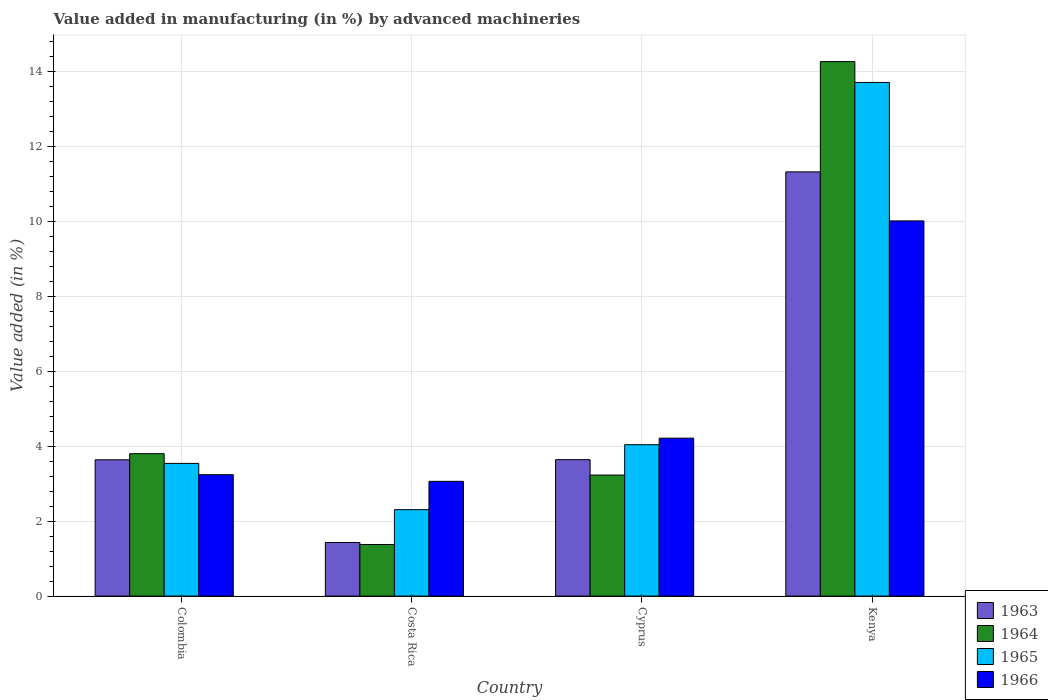How many different coloured bars are there?
Make the answer very short. 4. Are the number of bars on each tick of the X-axis equal?
Offer a terse response. Yes. How many bars are there on the 2nd tick from the left?
Provide a short and direct response. 4. How many bars are there on the 4th tick from the right?
Keep it short and to the point. 4. What is the label of the 4th group of bars from the left?
Give a very brief answer. Kenya. In how many cases, is the number of bars for a given country not equal to the number of legend labels?
Provide a succinct answer. 0. What is the percentage of value added in manufacturing by advanced machineries in 1965 in Kenya?
Offer a terse response. 13.71. Across all countries, what is the maximum percentage of value added in manufacturing by advanced machineries in 1965?
Your answer should be very brief. 13.71. Across all countries, what is the minimum percentage of value added in manufacturing by advanced machineries in 1963?
Provide a short and direct response. 1.43. In which country was the percentage of value added in manufacturing by advanced machineries in 1963 maximum?
Offer a terse response. Kenya. In which country was the percentage of value added in manufacturing by advanced machineries in 1964 minimum?
Your answer should be compact. Costa Rica. What is the total percentage of value added in manufacturing by advanced machineries in 1964 in the graph?
Make the answer very short. 22.68. What is the difference between the percentage of value added in manufacturing by advanced machineries in 1966 in Cyprus and that in Kenya?
Your answer should be compact. -5.8. What is the difference between the percentage of value added in manufacturing by advanced machineries in 1963 in Cyprus and the percentage of value added in manufacturing by advanced machineries in 1965 in Kenya?
Ensure brevity in your answer.  -10.07. What is the average percentage of value added in manufacturing by advanced machineries in 1966 per country?
Offer a very short reply. 5.13. What is the difference between the percentage of value added in manufacturing by advanced machineries of/in 1964 and percentage of value added in manufacturing by advanced machineries of/in 1966 in Colombia?
Provide a succinct answer. 0.56. What is the ratio of the percentage of value added in manufacturing by advanced machineries in 1966 in Costa Rica to that in Cyprus?
Your answer should be very brief. 0.73. What is the difference between the highest and the second highest percentage of value added in manufacturing by advanced machineries in 1966?
Give a very brief answer. 6.77. What is the difference between the highest and the lowest percentage of value added in manufacturing by advanced machineries in 1963?
Keep it short and to the point. 9.89. Is the sum of the percentage of value added in manufacturing by advanced machineries in 1964 in Colombia and Kenya greater than the maximum percentage of value added in manufacturing by advanced machineries in 1963 across all countries?
Offer a terse response. Yes. Is it the case that in every country, the sum of the percentage of value added in manufacturing by advanced machineries in 1964 and percentage of value added in manufacturing by advanced machineries in 1966 is greater than the sum of percentage of value added in manufacturing by advanced machineries in 1963 and percentage of value added in manufacturing by advanced machineries in 1965?
Give a very brief answer. No. What does the 1st bar from the left in Kenya represents?
Your response must be concise. 1963. What does the 1st bar from the right in Costa Rica represents?
Ensure brevity in your answer.  1966. Is it the case that in every country, the sum of the percentage of value added in manufacturing by advanced machineries in 1966 and percentage of value added in manufacturing by advanced machineries in 1964 is greater than the percentage of value added in manufacturing by advanced machineries in 1965?
Offer a very short reply. Yes. How many bars are there?
Keep it short and to the point. 16. Are all the bars in the graph horizontal?
Make the answer very short. No. Does the graph contain grids?
Offer a terse response. Yes. How are the legend labels stacked?
Offer a terse response. Vertical. What is the title of the graph?
Provide a short and direct response. Value added in manufacturing (in %) by advanced machineries. What is the label or title of the X-axis?
Your answer should be very brief. Country. What is the label or title of the Y-axis?
Offer a terse response. Value added (in %). What is the Value added (in %) of 1963 in Colombia?
Provide a short and direct response. 3.64. What is the Value added (in %) of 1964 in Colombia?
Your answer should be very brief. 3.8. What is the Value added (in %) in 1965 in Colombia?
Give a very brief answer. 3.54. What is the Value added (in %) of 1966 in Colombia?
Your answer should be very brief. 3.24. What is the Value added (in %) of 1963 in Costa Rica?
Keep it short and to the point. 1.43. What is the Value added (in %) of 1964 in Costa Rica?
Ensure brevity in your answer.  1.38. What is the Value added (in %) in 1965 in Costa Rica?
Provide a succinct answer. 2.31. What is the Value added (in %) in 1966 in Costa Rica?
Provide a succinct answer. 3.06. What is the Value added (in %) of 1963 in Cyprus?
Make the answer very short. 3.64. What is the Value added (in %) in 1964 in Cyprus?
Give a very brief answer. 3.23. What is the Value added (in %) of 1965 in Cyprus?
Give a very brief answer. 4.04. What is the Value added (in %) of 1966 in Cyprus?
Your response must be concise. 4.22. What is the Value added (in %) of 1963 in Kenya?
Keep it short and to the point. 11.32. What is the Value added (in %) in 1964 in Kenya?
Your answer should be very brief. 14.27. What is the Value added (in %) of 1965 in Kenya?
Keep it short and to the point. 13.71. What is the Value added (in %) in 1966 in Kenya?
Make the answer very short. 10.01. Across all countries, what is the maximum Value added (in %) of 1963?
Your response must be concise. 11.32. Across all countries, what is the maximum Value added (in %) of 1964?
Provide a short and direct response. 14.27. Across all countries, what is the maximum Value added (in %) of 1965?
Give a very brief answer. 13.71. Across all countries, what is the maximum Value added (in %) in 1966?
Provide a succinct answer. 10.01. Across all countries, what is the minimum Value added (in %) in 1963?
Offer a very short reply. 1.43. Across all countries, what is the minimum Value added (in %) of 1964?
Your answer should be compact. 1.38. Across all countries, what is the minimum Value added (in %) of 1965?
Your answer should be very brief. 2.31. Across all countries, what is the minimum Value added (in %) in 1966?
Offer a very short reply. 3.06. What is the total Value added (in %) in 1963 in the graph?
Your answer should be very brief. 20.03. What is the total Value added (in %) in 1964 in the graph?
Your response must be concise. 22.68. What is the total Value added (in %) in 1965 in the graph?
Ensure brevity in your answer.  23.6. What is the total Value added (in %) of 1966 in the graph?
Offer a terse response. 20.53. What is the difference between the Value added (in %) in 1963 in Colombia and that in Costa Rica?
Your answer should be very brief. 2.21. What is the difference between the Value added (in %) of 1964 in Colombia and that in Costa Rica?
Your response must be concise. 2.42. What is the difference between the Value added (in %) of 1965 in Colombia and that in Costa Rica?
Keep it short and to the point. 1.24. What is the difference between the Value added (in %) of 1966 in Colombia and that in Costa Rica?
Keep it short and to the point. 0.18. What is the difference between the Value added (in %) in 1963 in Colombia and that in Cyprus?
Your response must be concise. -0. What is the difference between the Value added (in %) of 1964 in Colombia and that in Cyprus?
Keep it short and to the point. 0.57. What is the difference between the Value added (in %) in 1965 in Colombia and that in Cyprus?
Keep it short and to the point. -0.5. What is the difference between the Value added (in %) of 1966 in Colombia and that in Cyprus?
Offer a very short reply. -0.97. What is the difference between the Value added (in %) in 1963 in Colombia and that in Kenya?
Your response must be concise. -7.69. What is the difference between the Value added (in %) of 1964 in Colombia and that in Kenya?
Offer a terse response. -10.47. What is the difference between the Value added (in %) of 1965 in Colombia and that in Kenya?
Provide a short and direct response. -10.17. What is the difference between the Value added (in %) of 1966 in Colombia and that in Kenya?
Offer a very short reply. -6.77. What is the difference between the Value added (in %) in 1963 in Costa Rica and that in Cyprus?
Your response must be concise. -2.21. What is the difference between the Value added (in %) of 1964 in Costa Rica and that in Cyprus?
Your response must be concise. -1.85. What is the difference between the Value added (in %) in 1965 in Costa Rica and that in Cyprus?
Your answer should be very brief. -1.73. What is the difference between the Value added (in %) of 1966 in Costa Rica and that in Cyprus?
Your response must be concise. -1.15. What is the difference between the Value added (in %) in 1963 in Costa Rica and that in Kenya?
Provide a short and direct response. -9.89. What is the difference between the Value added (in %) of 1964 in Costa Rica and that in Kenya?
Offer a terse response. -12.89. What is the difference between the Value added (in %) of 1965 in Costa Rica and that in Kenya?
Offer a very short reply. -11.4. What is the difference between the Value added (in %) of 1966 in Costa Rica and that in Kenya?
Give a very brief answer. -6.95. What is the difference between the Value added (in %) of 1963 in Cyprus and that in Kenya?
Provide a short and direct response. -7.68. What is the difference between the Value added (in %) of 1964 in Cyprus and that in Kenya?
Ensure brevity in your answer.  -11.04. What is the difference between the Value added (in %) of 1965 in Cyprus and that in Kenya?
Offer a terse response. -9.67. What is the difference between the Value added (in %) in 1966 in Cyprus and that in Kenya?
Your answer should be compact. -5.8. What is the difference between the Value added (in %) in 1963 in Colombia and the Value added (in %) in 1964 in Costa Rica?
Your answer should be compact. 2.26. What is the difference between the Value added (in %) in 1963 in Colombia and the Value added (in %) in 1965 in Costa Rica?
Your answer should be compact. 1.33. What is the difference between the Value added (in %) in 1963 in Colombia and the Value added (in %) in 1966 in Costa Rica?
Your answer should be compact. 0.57. What is the difference between the Value added (in %) in 1964 in Colombia and the Value added (in %) in 1965 in Costa Rica?
Make the answer very short. 1.49. What is the difference between the Value added (in %) of 1964 in Colombia and the Value added (in %) of 1966 in Costa Rica?
Provide a succinct answer. 0.74. What is the difference between the Value added (in %) of 1965 in Colombia and the Value added (in %) of 1966 in Costa Rica?
Make the answer very short. 0.48. What is the difference between the Value added (in %) of 1963 in Colombia and the Value added (in %) of 1964 in Cyprus?
Offer a terse response. 0.41. What is the difference between the Value added (in %) in 1963 in Colombia and the Value added (in %) in 1965 in Cyprus?
Offer a very short reply. -0.4. What is the difference between the Value added (in %) of 1963 in Colombia and the Value added (in %) of 1966 in Cyprus?
Your answer should be compact. -0.58. What is the difference between the Value added (in %) in 1964 in Colombia and the Value added (in %) in 1965 in Cyprus?
Make the answer very short. -0.24. What is the difference between the Value added (in %) in 1964 in Colombia and the Value added (in %) in 1966 in Cyprus?
Ensure brevity in your answer.  -0.41. What is the difference between the Value added (in %) of 1965 in Colombia and the Value added (in %) of 1966 in Cyprus?
Offer a very short reply. -0.67. What is the difference between the Value added (in %) of 1963 in Colombia and the Value added (in %) of 1964 in Kenya?
Give a very brief answer. -10.63. What is the difference between the Value added (in %) of 1963 in Colombia and the Value added (in %) of 1965 in Kenya?
Your answer should be very brief. -10.07. What is the difference between the Value added (in %) in 1963 in Colombia and the Value added (in %) in 1966 in Kenya?
Your response must be concise. -6.38. What is the difference between the Value added (in %) in 1964 in Colombia and the Value added (in %) in 1965 in Kenya?
Offer a very short reply. -9.91. What is the difference between the Value added (in %) of 1964 in Colombia and the Value added (in %) of 1966 in Kenya?
Give a very brief answer. -6.21. What is the difference between the Value added (in %) in 1965 in Colombia and the Value added (in %) in 1966 in Kenya?
Make the answer very short. -6.47. What is the difference between the Value added (in %) of 1963 in Costa Rica and the Value added (in %) of 1964 in Cyprus?
Give a very brief answer. -1.8. What is the difference between the Value added (in %) in 1963 in Costa Rica and the Value added (in %) in 1965 in Cyprus?
Provide a succinct answer. -2.61. What is the difference between the Value added (in %) in 1963 in Costa Rica and the Value added (in %) in 1966 in Cyprus?
Offer a very short reply. -2.78. What is the difference between the Value added (in %) of 1964 in Costa Rica and the Value added (in %) of 1965 in Cyprus?
Offer a very short reply. -2.66. What is the difference between the Value added (in %) of 1964 in Costa Rica and the Value added (in %) of 1966 in Cyprus?
Make the answer very short. -2.84. What is the difference between the Value added (in %) of 1965 in Costa Rica and the Value added (in %) of 1966 in Cyprus?
Offer a terse response. -1.91. What is the difference between the Value added (in %) in 1963 in Costa Rica and the Value added (in %) in 1964 in Kenya?
Your answer should be very brief. -12.84. What is the difference between the Value added (in %) of 1963 in Costa Rica and the Value added (in %) of 1965 in Kenya?
Provide a succinct answer. -12.28. What is the difference between the Value added (in %) in 1963 in Costa Rica and the Value added (in %) in 1966 in Kenya?
Offer a very short reply. -8.58. What is the difference between the Value added (in %) in 1964 in Costa Rica and the Value added (in %) in 1965 in Kenya?
Ensure brevity in your answer.  -12.33. What is the difference between the Value added (in %) of 1964 in Costa Rica and the Value added (in %) of 1966 in Kenya?
Give a very brief answer. -8.64. What is the difference between the Value added (in %) of 1965 in Costa Rica and the Value added (in %) of 1966 in Kenya?
Your answer should be compact. -7.71. What is the difference between the Value added (in %) in 1963 in Cyprus and the Value added (in %) in 1964 in Kenya?
Your response must be concise. -10.63. What is the difference between the Value added (in %) of 1963 in Cyprus and the Value added (in %) of 1965 in Kenya?
Provide a short and direct response. -10.07. What is the difference between the Value added (in %) in 1963 in Cyprus and the Value added (in %) in 1966 in Kenya?
Provide a short and direct response. -6.37. What is the difference between the Value added (in %) in 1964 in Cyprus and the Value added (in %) in 1965 in Kenya?
Offer a terse response. -10.48. What is the difference between the Value added (in %) in 1964 in Cyprus and the Value added (in %) in 1966 in Kenya?
Your answer should be very brief. -6.78. What is the difference between the Value added (in %) in 1965 in Cyprus and the Value added (in %) in 1966 in Kenya?
Offer a terse response. -5.97. What is the average Value added (in %) of 1963 per country?
Keep it short and to the point. 5.01. What is the average Value added (in %) in 1964 per country?
Your response must be concise. 5.67. What is the average Value added (in %) of 1965 per country?
Make the answer very short. 5.9. What is the average Value added (in %) in 1966 per country?
Your answer should be very brief. 5.13. What is the difference between the Value added (in %) of 1963 and Value added (in %) of 1964 in Colombia?
Your answer should be compact. -0.16. What is the difference between the Value added (in %) of 1963 and Value added (in %) of 1965 in Colombia?
Offer a terse response. 0.1. What is the difference between the Value added (in %) in 1963 and Value added (in %) in 1966 in Colombia?
Your response must be concise. 0.4. What is the difference between the Value added (in %) in 1964 and Value added (in %) in 1965 in Colombia?
Provide a succinct answer. 0.26. What is the difference between the Value added (in %) in 1964 and Value added (in %) in 1966 in Colombia?
Your response must be concise. 0.56. What is the difference between the Value added (in %) of 1965 and Value added (in %) of 1966 in Colombia?
Offer a terse response. 0.3. What is the difference between the Value added (in %) in 1963 and Value added (in %) in 1964 in Costa Rica?
Ensure brevity in your answer.  0.05. What is the difference between the Value added (in %) in 1963 and Value added (in %) in 1965 in Costa Rica?
Offer a very short reply. -0.88. What is the difference between the Value added (in %) of 1963 and Value added (in %) of 1966 in Costa Rica?
Keep it short and to the point. -1.63. What is the difference between the Value added (in %) in 1964 and Value added (in %) in 1965 in Costa Rica?
Provide a succinct answer. -0.93. What is the difference between the Value added (in %) in 1964 and Value added (in %) in 1966 in Costa Rica?
Provide a short and direct response. -1.69. What is the difference between the Value added (in %) of 1965 and Value added (in %) of 1966 in Costa Rica?
Give a very brief answer. -0.76. What is the difference between the Value added (in %) in 1963 and Value added (in %) in 1964 in Cyprus?
Provide a succinct answer. 0.41. What is the difference between the Value added (in %) of 1963 and Value added (in %) of 1965 in Cyprus?
Ensure brevity in your answer.  -0.4. What is the difference between the Value added (in %) in 1963 and Value added (in %) in 1966 in Cyprus?
Ensure brevity in your answer.  -0.57. What is the difference between the Value added (in %) of 1964 and Value added (in %) of 1965 in Cyprus?
Give a very brief answer. -0.81. What is the difference between the Value added (in %) of 1964 and Value added (in %) of 1966 in Cyprus?
Offer a very short reply. -0.98. What is the difference between the Value added (in %) of 1965 and Value added (in %) of 1966 in Cyprus?
Offer a very short reply. -0.17. What is the difference between the Value added (in %) in 1963 and Value added (in %) in 1964 in Kenya?
Provide a short and direct response. -2.94. What is the difference between the Value added (in %) of 1963 and Value added (in %) of 1965 in Kenya?
Your response must be concise. -2.39. What is the difference between the Value added (in %) in 1963 and Value added (in %) in 1966 in Kenya?
Offer a terse response. 1.31. What is the difference between the Value added (in %) of 1964 and Value added (in %) of 1965 in Kenya?
Offer a terse response. 0.56. What is the difference between the Value added (in %) of 1964 and Value added (in %) of 1966 in Kenya?
Make the answer very short. 4.25. What is the difference between the Value added (in %) of 1965 and Value added (in %) of 1966 in Kenya?
Offer a terse response. 3.7. What is the ratio of the Value added (in %) of 1963 in Colombia to that in Costa Rica?
Offer a very short reply. 2.54. What is the ratio of the Value added (in %) of 1964 in Colombia to that in Costa Rica?
Offer a terse response. 2.76. What is the ratio of the Value added (in %) of 1965 in Colombia to that in Costa Rica?
Keep it short and to the point. 1.54. What is the ratio of the Value added (in %) in 1966 in Colombia to that in Costa Rica?
Your response must be concise. 1.06. What is the ratio of the Value added (in %) of 1964 in Colombia to that in Cyprus?
Provide a succinct answer. 1.18. What is the ratio of the Value added (in %) in 1965 in Colombia to that in Cyprus?
Provide a succinct answer. 0.88. What is the ratio of the Value added (in %) of 1966 in Colombia to that in Cyprus?
Give a very brief answer. 0.77. What is the ratio of the Value added (in %) in 1963 in Colombia to that in Kenya?
Your answer should be very brief. 0.32. What is the ratio of the Value added (in %) in 1964 in Colombia to that in Kenya?
Provide a short and direct response. 0.27. What is the ratio of the Value added (in %) in 1965 in Colombia to that in Kenya?
Your response must be concise. 0.26. What is the ratio of the Value added (in %) of 1966 in Colombia to that in Kenya?
Your answer should be very brief. 0.32. What is the ratio of the Value added (in %) in 1963 in Costa Rica to that in Cyprus?
Give a very brief answer. 0.39. What is the ratio of the Value added (in %) in 1964 in Costa Rica to that in Cyprus?
Provide a short and direct response. 0.43. What is the ratio of the Value added (in %) of 1965 in Costa Rica to that in Cyprus?
Keep it short and to the point. 0.57. What is the ratio of the Value added (in %) in 1966 in Costa Rica to that in Cyprus?
Offer a very short reply. 0.73. What is the ratio of the Value added (in %) in 1963 in Costa Rica to that in Kenya?
Provide a succinct answer. 0.13. What is the ratio of the Value added (in %) in 1964 in Costa Rica to that in Kenya?
Provide a succinct answer. 0.1. What is the ratio of the Value added (in %) in 1965 in Costa Rica to that in Kenya?
Offer a terse response. 0.17. What is the ratio of the Value added (in %) in 1966 in Costa Rica to that in Kenya?
Your answer should be very brief. 0.31. What is the ratio of the Value added (in %) in 1963 in Cyprus to that in Kenya?
Ensure brevity in your answer.  0.32. What is the ratio of the Value added (in %) in 1964 in Cyprus to that in Kenya?
Your answer should be very brief. 0.23. What is the ratio of the Value added (in %) of 1965 in Cyprus to that in Kenya?
Your answer should be compact. 0.29. What is the ratio of the Value added (in %) of 1966 in Cyprus to that in Kenya?
Offer a terse response. 0.42. What is the difference between the highest and the second highest Value added (in %) of 1963?
Your answer should be compact. 7.68. What is the difference between the highest and the second highest Value added (in %) of 1964?
Give a very brief answer. 10.47. What is the difference between the highest and the second highest Value added (in %) in 1965?
Keep it short and to the point. 9.67. What is the difference between the highest and the second highest Value added (in %) in 1966?
Your response must be concise. 5.8. What is the difference between the highest and the lowest Value added (in %) of 1963?
Provide a succinct answer. 9.89. What is the difference between the highest and the lowest Value added (in %) in 1964?
Give a very brief answer. 12.89. What is the difference between the highest and the lowest Value added (in %) of 1965?
Offer a very short reply. 11.4. What is the difference between the highest and the lowest Value added (in %) of 1966?
Your answer should be compact. 6.95. 